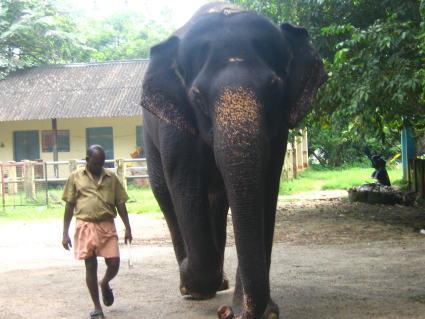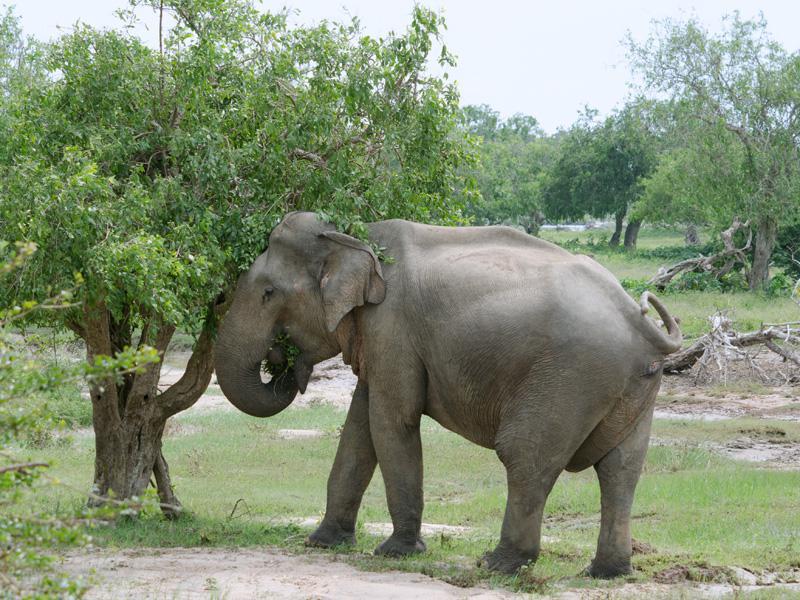The first image is the image on the left, the second image is the image on the right. Evaluate the accuracy of this statement regarding the images: "In the image to the right, the elephant is right before a tree.". Is it true? Answer yes or no. Yes. 